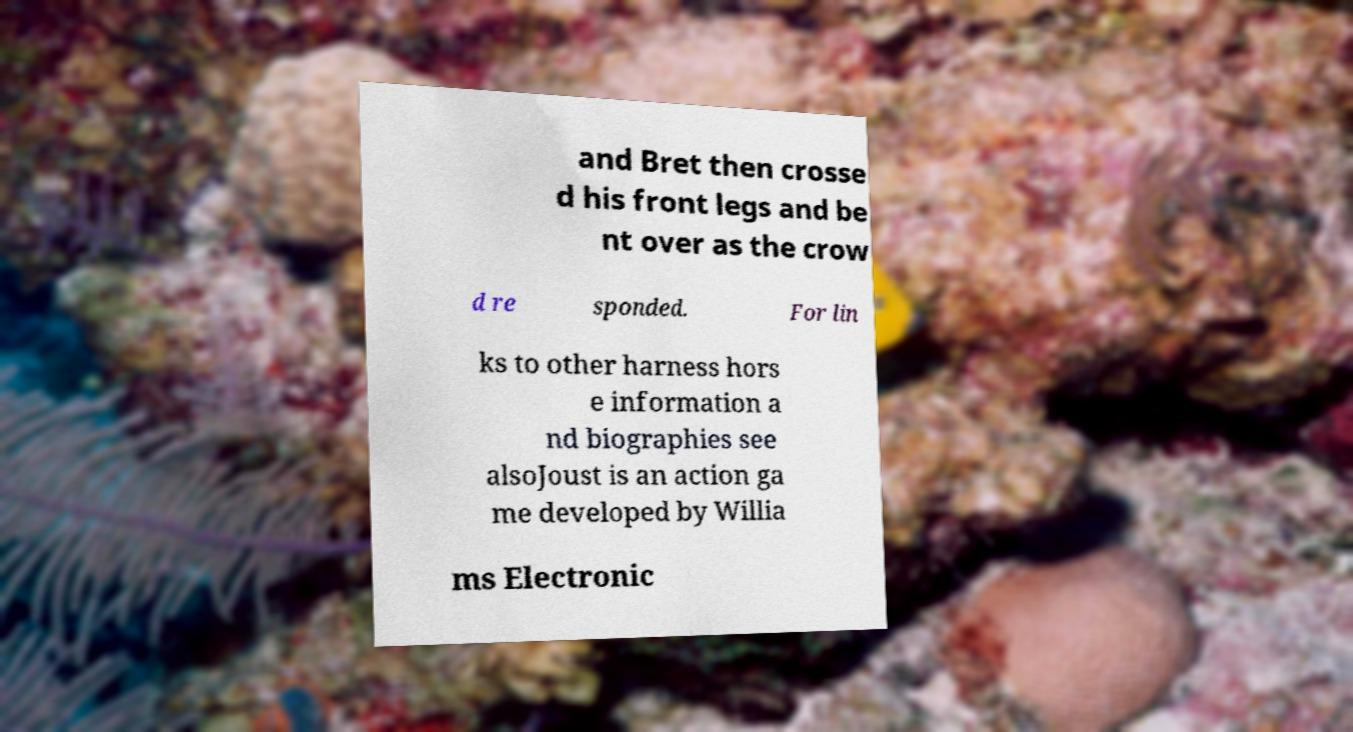Can you read and provide the text displayed in the image?This photo seems to have some interesting text. Can you extract and type it out for me? and Bret then crosse d his front legs and be nt over as the crow d re sponded. For lin ks to other harness hors e information a nd biographies see alsoJoust is an action ga me developed by Willia ms Electronic 